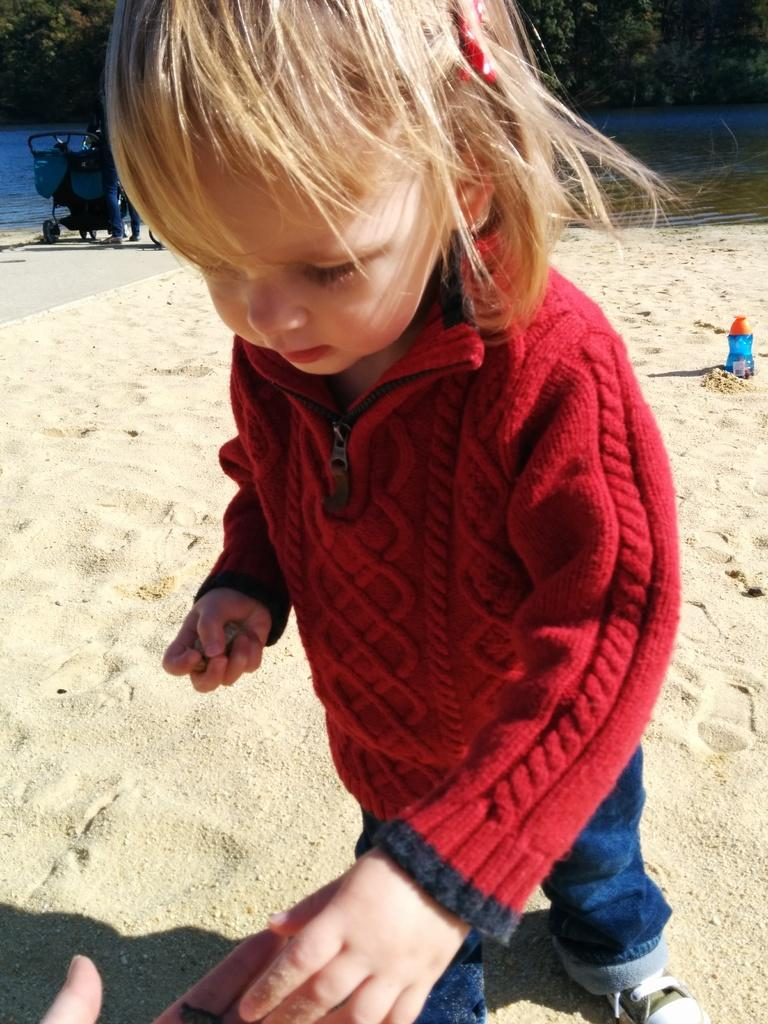Who is the main subject in the image? There is a girl standing in the center of the image. What is the girl standing on? The girl is standing on the sand. What can be seen in the background of the image? There is a vehicle, water, and trees visible in the background of the image. What type of calendar is hanging on the tree in the image? There is no calendar present in the image; it features a girl standing on the sand with a vehicle, water, and trees visible in the background. 